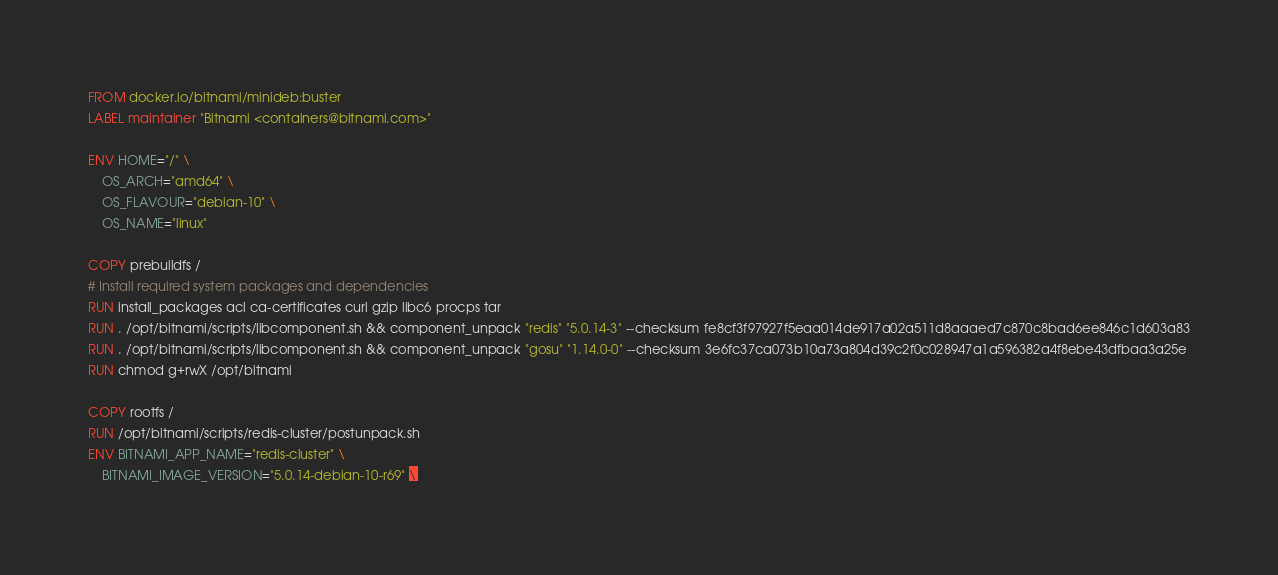Convert code to text. <code><loc_0><loc_0><loc_500><loc_500><_Dockerfile_>FROM docker.io/bitnami/minideb:buster
LABEL maintainer "Bitnami <containers@bitnami.com>"

ENV HOME="/" \
    OS_ARCH="amd64" \
    OS_FLAVOUR="debian-10" \
    OS_NAME="linux"

COPY prebuildfs /
# Install required system packages and dependencies
RUN install_packages acl ca-certificates curl gzip libc6 procps tar
RUN . /opt/bitnami/scripts/libcomponent.sh && component_unpack "redis" "5.0.14-3" --checksum fe8cf3f97927f5eaa014de917a02a511d8aaaed7c870c8bad6ee846c1d603a83
RUN . /opt/bitnami/scripts/libcomponent.sh && component_unpack "gosu" "1.14.0-0" --checksum 3e6fc37ca073b10a73a804d39c2f0c028947a1a596382a4f8ebe43dfbaa3a25e
RUN chmod g+rwX /opt/bitnami

COPY rootfs /
RUN /opt/bitnami/scripts/redis-cluster/postunpack.sh
ENV BITNAMI_APP_NAME="redis-cluster" \
    BITNAMI_IMAGE_VERSION="5.0.14-debian-10-r69" \</code> 